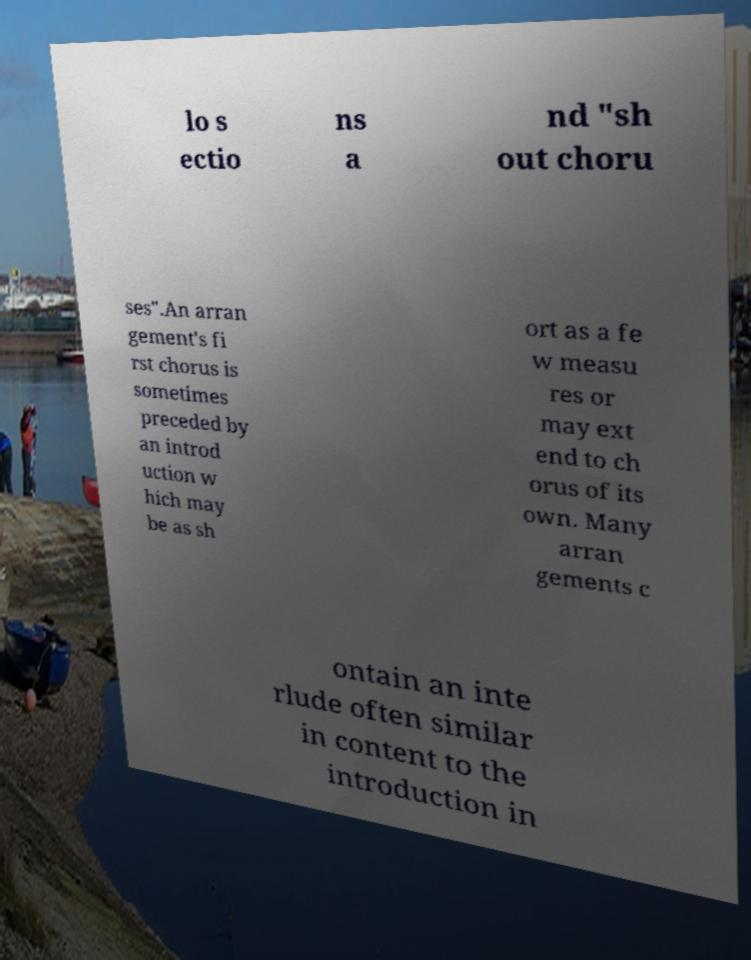Please identify and transcribe the text found in this image. lo s ectio ns a nd "sh out choru ses".An arran gement's fi rst chorus is sometimes preceded by an introd uction w hich may be as sh ort as a fe w measu res or may ext end to ch orus of its own. Many arran gements c ontain an inte rlude often similar in content to the introduction in 